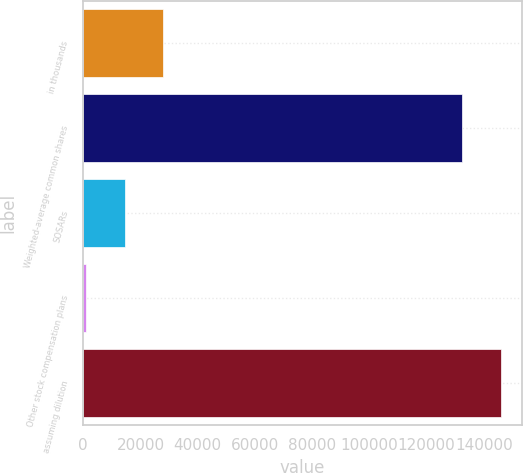<chart> <loc_0><loc_0><loc_500><loc_500><bar_chart><fcel>in thousands<fcel>Weighted-average common shares<fcel>SOSARs<fcel>Other stock compensation plans<fcel>assuming dilution<nl><fcel>27831.6<fcel>132513<fcel>14450.8<fcel>1070<fcel>145894<nl></chart> 